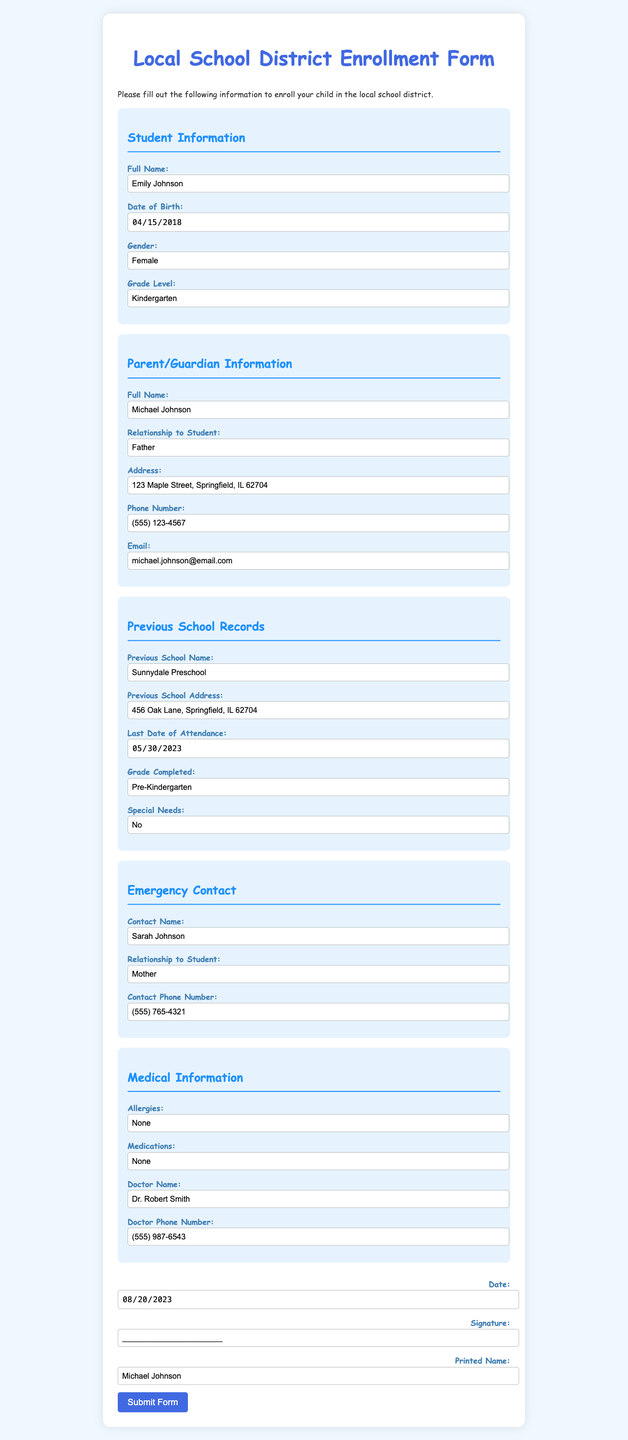What is the student's full name? The full name of the student is listed in the document under Student Information.
Answer: Emily Johnson What is the date of birth of the student? The date of birth is specified in the Student Information section of the document.
Answer: 2018-04-15 What is the grade level of the student? The grade level is noted in the Student Information section of the document.
Answer: Kindergarten What is the name of the previous school attended? The name of the previous school is recorded under Previous School Records.
Answer: Sunnydale Preschool What is the last date of attendance at the previous school? The last date of attendance is indicated in the Previous School Records section.
Answer: 2023-05-30 Who is the emergency contact? The emergency contact is provided in the Emergency Contact section of the document.
Answer: Sarah Johnson What is the contact phone number for the emergency contact? The contact phone number for the emergency contact is listed in the Emergency Contact section.
Answer: (555) 765-4321 What are the allergies listed for the student? The allergies are specified in the Medical Information section of the document.
Answer: None What is the name of the student's doctor? The doctor's name is mentioned in the Medical Information section.
Answer: Dr. Robert Smith 